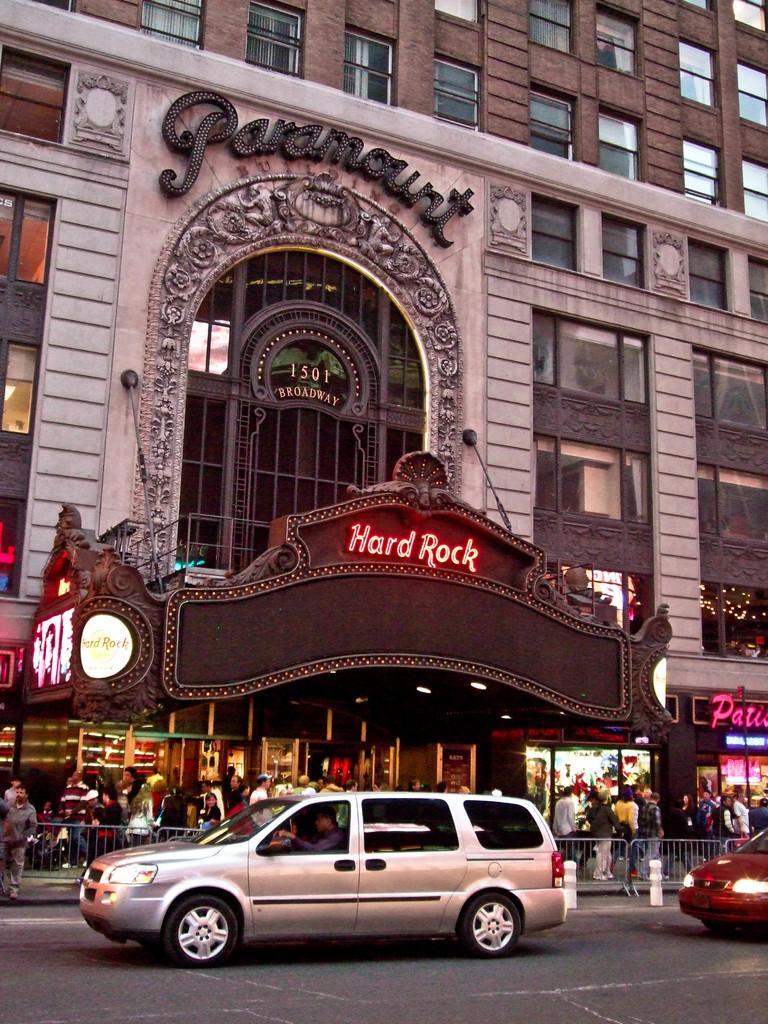How would you summarize this image in a sentence or two? In the image I can see the road. I can see vehicles and people walking. In the background, I can see buildings and some text. I can see windows with glasses.  